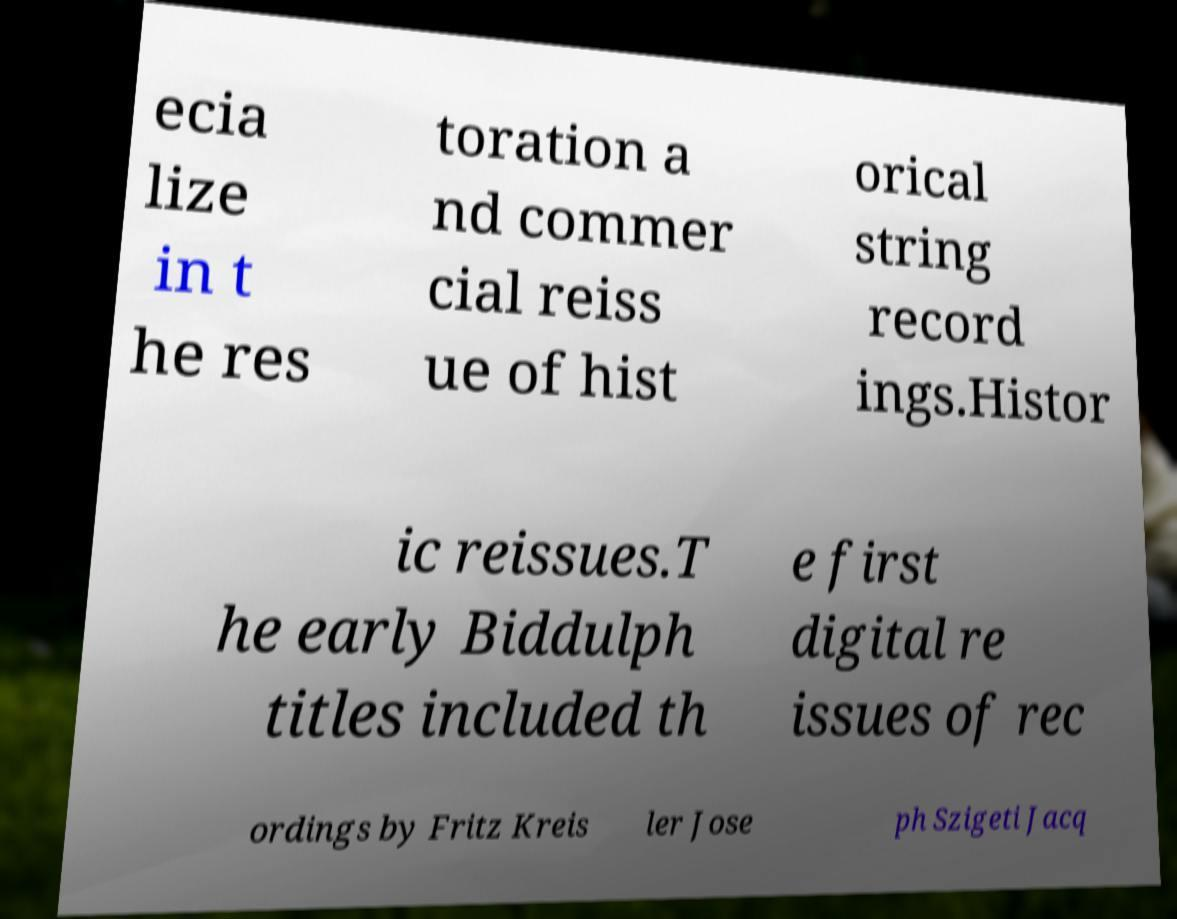For documentation purposes, I need the text within this image transcribed. Could you provide that? ecia lize in t he res toration a nd commer cial reiss ue of hist orical string record ings.Histor ic reissues.T he early Biddulph titles included th e first digital re issues of rec ordings by Fritz Kreis ler Jose ph Szigeti Jacq 